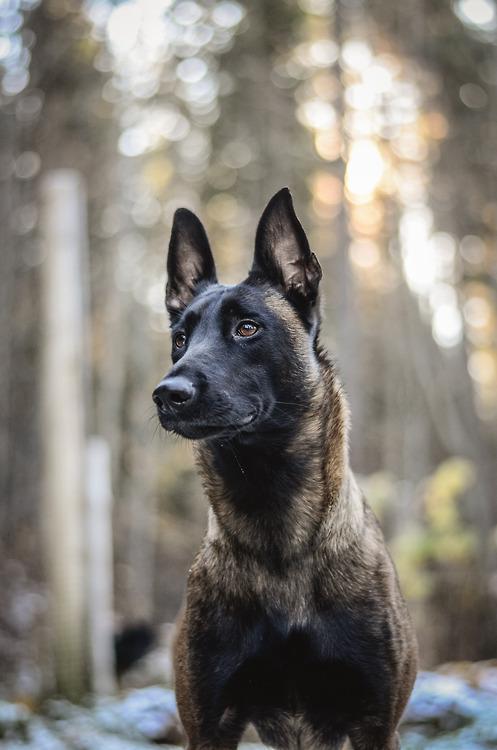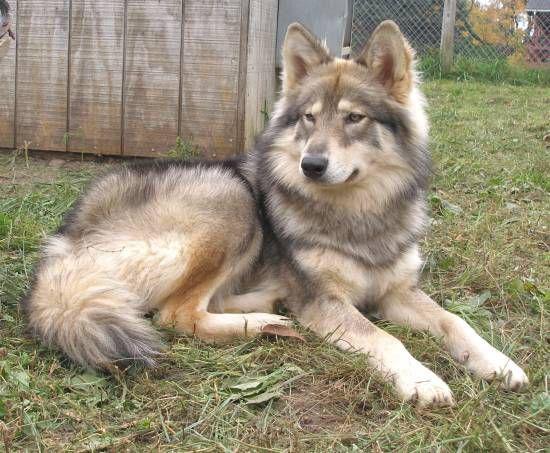The first image is the image on the left, the second image is the image on the right. Evaluate the accuracy of this statement regarding the images: "One of the images shows a dog completely in the air.". Is it true? Answer yes or no. No. The first image is the image on the left, the second image is the image on the right. Evaluate the accuracy of this statement regarding the images: "A dog is shown with only one soldier in one image". Is it true? Answer yes or no. No. 